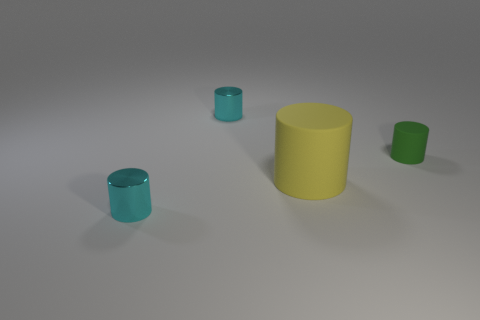Add 4 green objects. How many objects exist? 8 Add 1 matte cylinders. How many matte cylinders exist? 3 Subtract 0 cyan blocks. How many objects are left? 4 Subtract all tiny cyan shiny things. Subtract all big yellow matte objects. How many objects are left? 1 Add 3 tiny rubber cylinders. How many tiny rubber cylinders are left? 4 